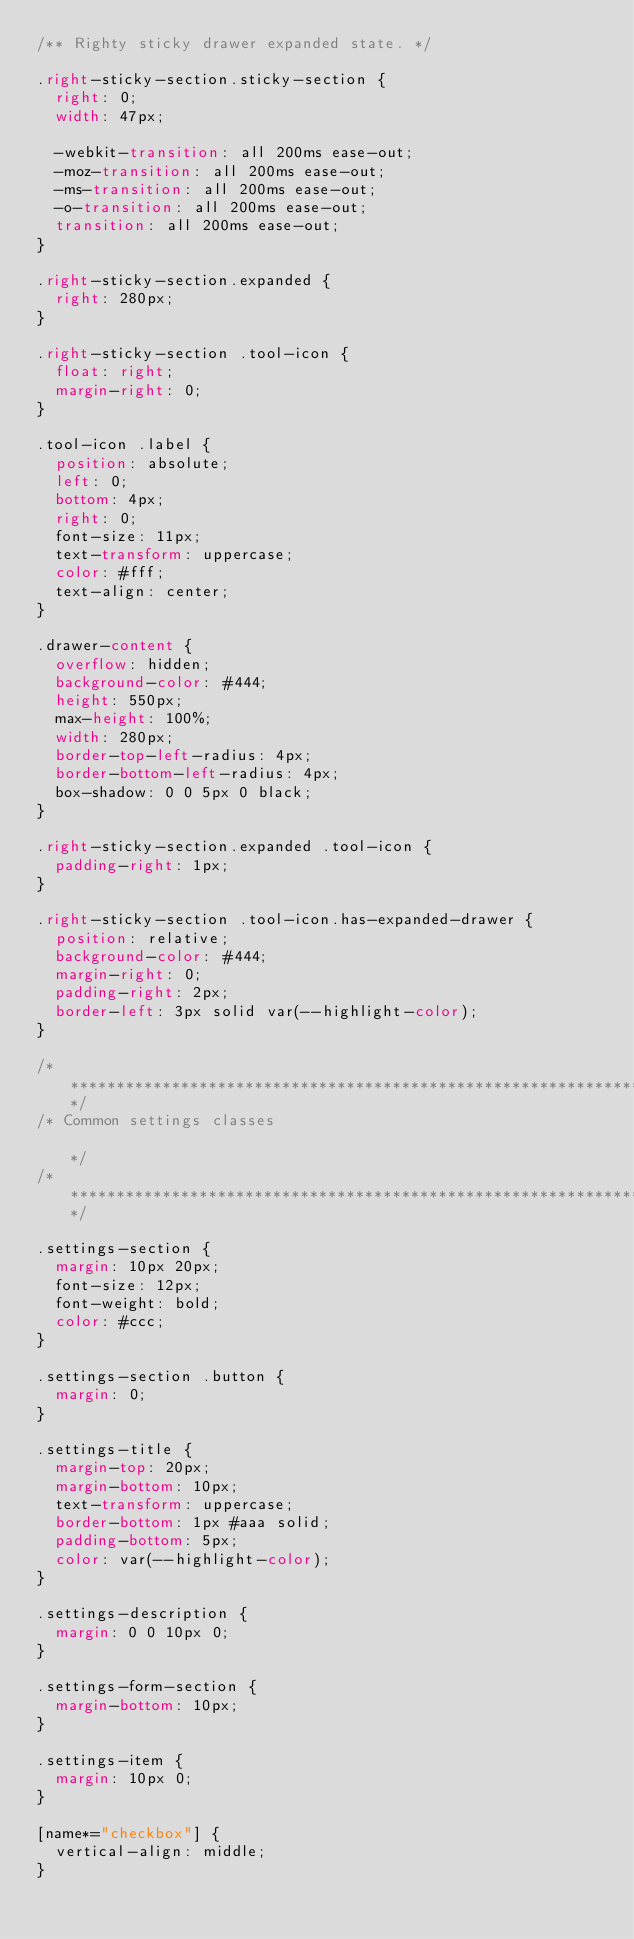Convert code to text. <code><loc_0><loc_0><loc_500><loc_500><_CSS_>/** Righty sticky drawer expanded state. */

.right-sticky-section.sticky-section {
  right: 0;
  width: 47px;

  -webkit-transition: all 200ms ease-out;
  -moz-transition: all 200ms ease-out;
  -ms-transition: all 200ms ease-out;
  -o-transition: all 200ms ease-out;
  transition: all 200ms ease-out;
}

.right-sticky-section.expanded {
  right: 280px;
}

.right-sticky-section .tool-icon {
  float: right;
  margin-right: 0;
}

.tool-icon .label {
  position: absolute;
  left: 0;
  bottom: 4px;
  right: 0;
  font-size: 11px;
  text-transform: uppercase;
  color: #fff;
  text-align: center;
}

.drawer-content {
  overflow: hidden;
  background-color: #444;
  height: 550px;
  max-height: 100%;
  width: 280px;
  border-top-left-radius: 4px;
  border-bottom-left-radius: 4px;
  box-shadow: 0 0 5px 0 black;
}

.right-sticky-section.expanded .tool-icon {
  padding-right: 1px;
}

.right-sticky-section .tool-icon.has-expanded-drawer {
  position: relative;
  background-color: #444;
  margin-right: 0;
  padding-right: 2px;
  border-left: 3px solid var(--highlight-color);
}

/************************************************************************************************/
/* Common settings classes                                                                      */
/************************************************************************************************/

.settings-section {
  margin: 10px 20px;
  font-size: 12px;
  font-weight: bold;
  color: #ccc;
}

.settings-section .button {
  margin: 0;
}

.settings-title {
  margin-top: 20px;
  margin-bottom: 10px;
  text-transform: uppercase;
  border-bottom: 1px #aaa solid;
  padding-bottom: 5px;
  color: var(--highlight-color);
}

.settings-description {
  margin: 0 0 10px 0;
}

.settings-form-section {
  margin-bottom: 10px;
}

.settings-item {
  margin: 10px 0;
}

[name*="checkbox"] {
  vertical-align: middle;
}
</code> 